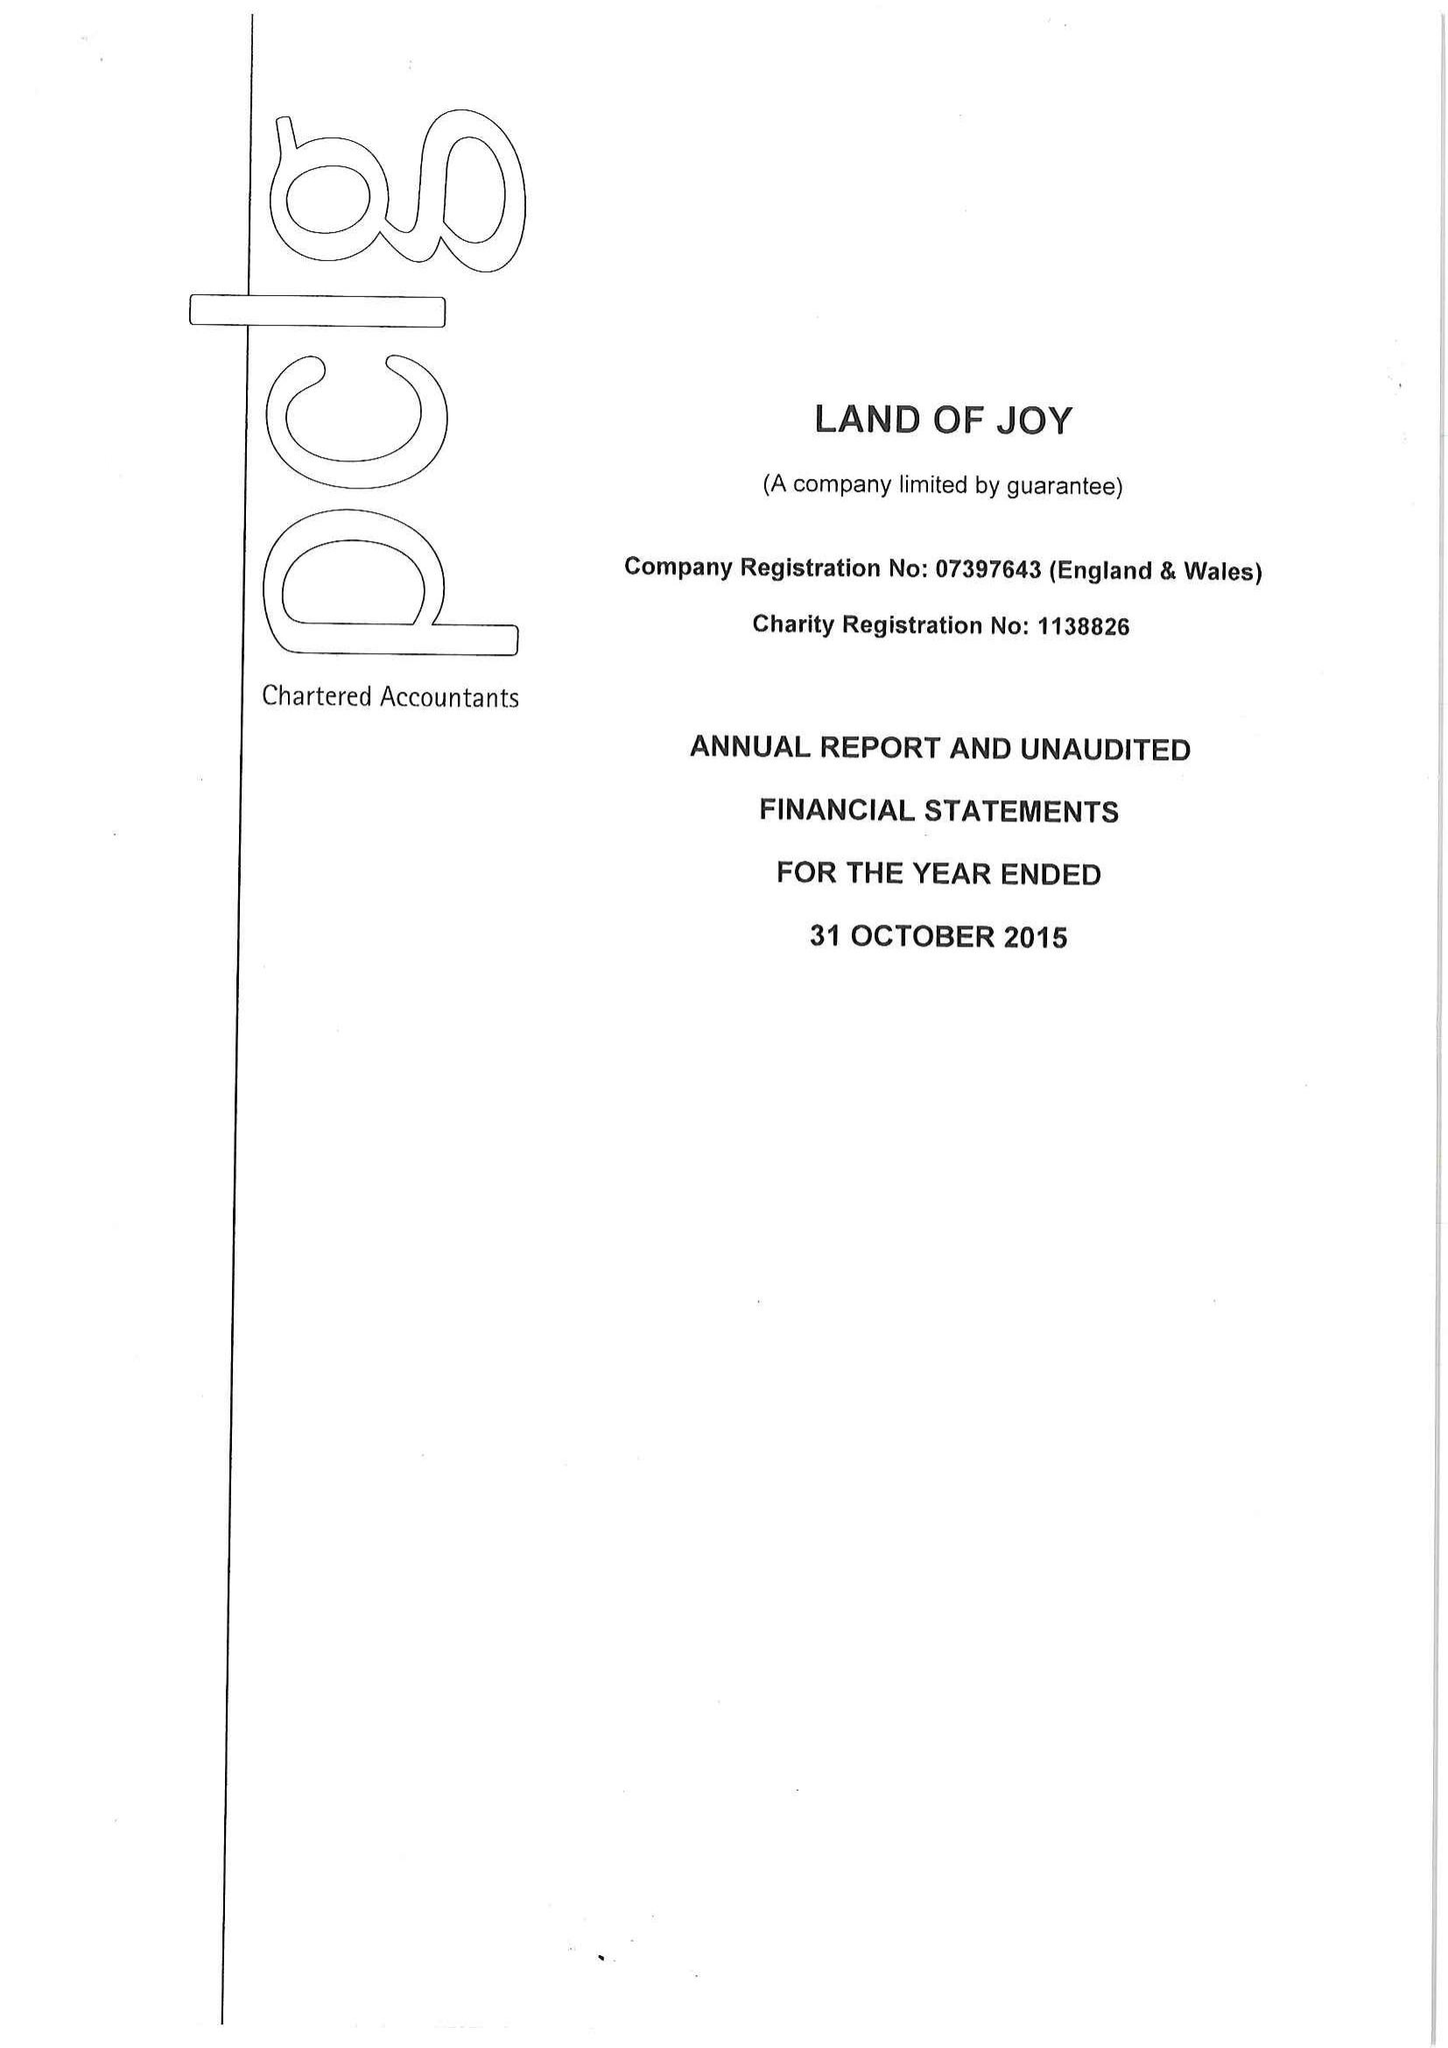What is the value for the charity_name?
Answer the question using a single word or phrase. Land Of Joy 